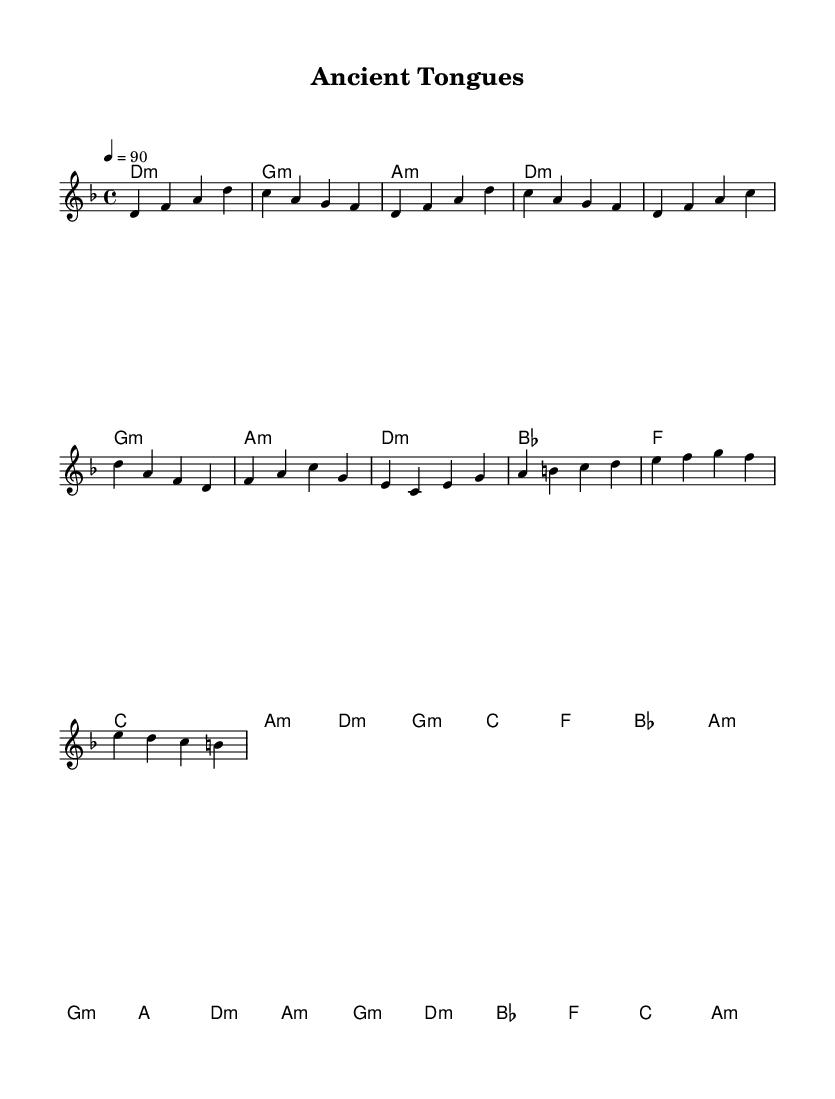What is the key signature of this music? The key signature is indicated by the key of D minor, which has one flat (B flat).
Answer: D minor What is the time signature of this music? The time signature is located at the beginning of the music staff and shows that there are four beats in each measure.
Answer: 4/4 What is the tempo marking for this piece? The tempo marking, which indicates the speed of the music, is set to a quarter note equals 90 beats per minute.
Answer: 90 How many measures are in the verse section? By examining the melody, the verse section consists of two phrases, each with four measures, resulting in a total of eight measures.
Answer: 8 In which section does the chord progression contain the chord "C"? The chord "C" appears in the verse after the G minor and precedes the A minor, indicating its location in the overall harmonic progression.
Answer: Verse What is the corresponding chorus melody note for the chord "G"? The note "B" corresponds to the G chord in the chorus, as the melody outlines the notes derived from the harmony for that measure.
Answer: B 